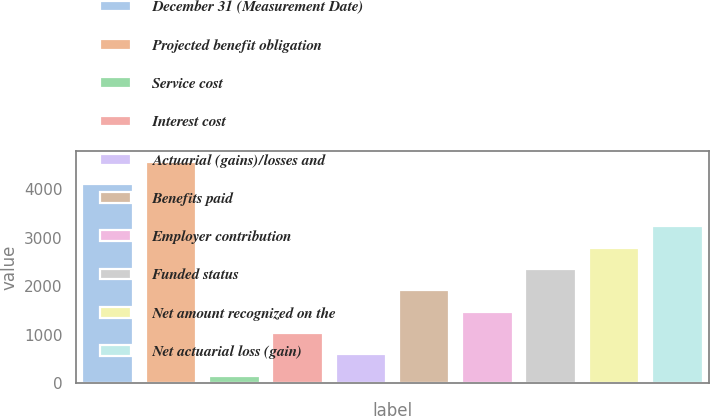Convert chart to OTSL. <chart><loc_0><loc_0><loc_500><loc_500><bar_chart><fcel>December 31 (Measurement Date)<fcel>Projected benefit obligation<fcel>Service cost<fcel>Interest cost<fcel>Actuarial (gains)/losses and<fcel>Benefits paid<fcel>Employer contribution<fcel>Funded status<fcel>Net amount recognized on the<fcel>Net actuarial loss (gain)<nl><fcel>4108.3<fcel>4547<fcel>160<fcel>1037.4<fcel>598.7<fcel>1914.8<fcel>1476.1<fcel>2353.5<fcel>2792.2<fcel>3230.9<nl></chart> 